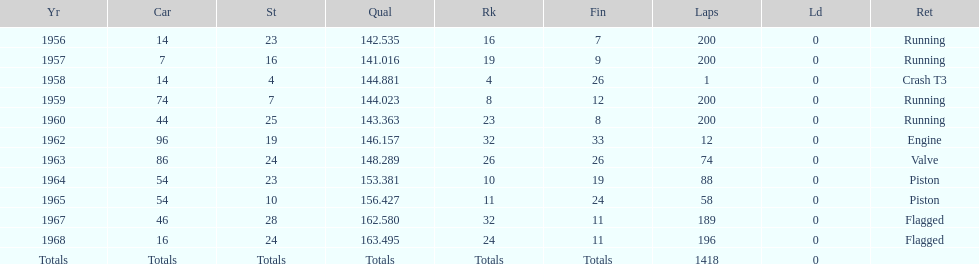In which year did he possess a car with the same number as the one in 1964? 1965. 